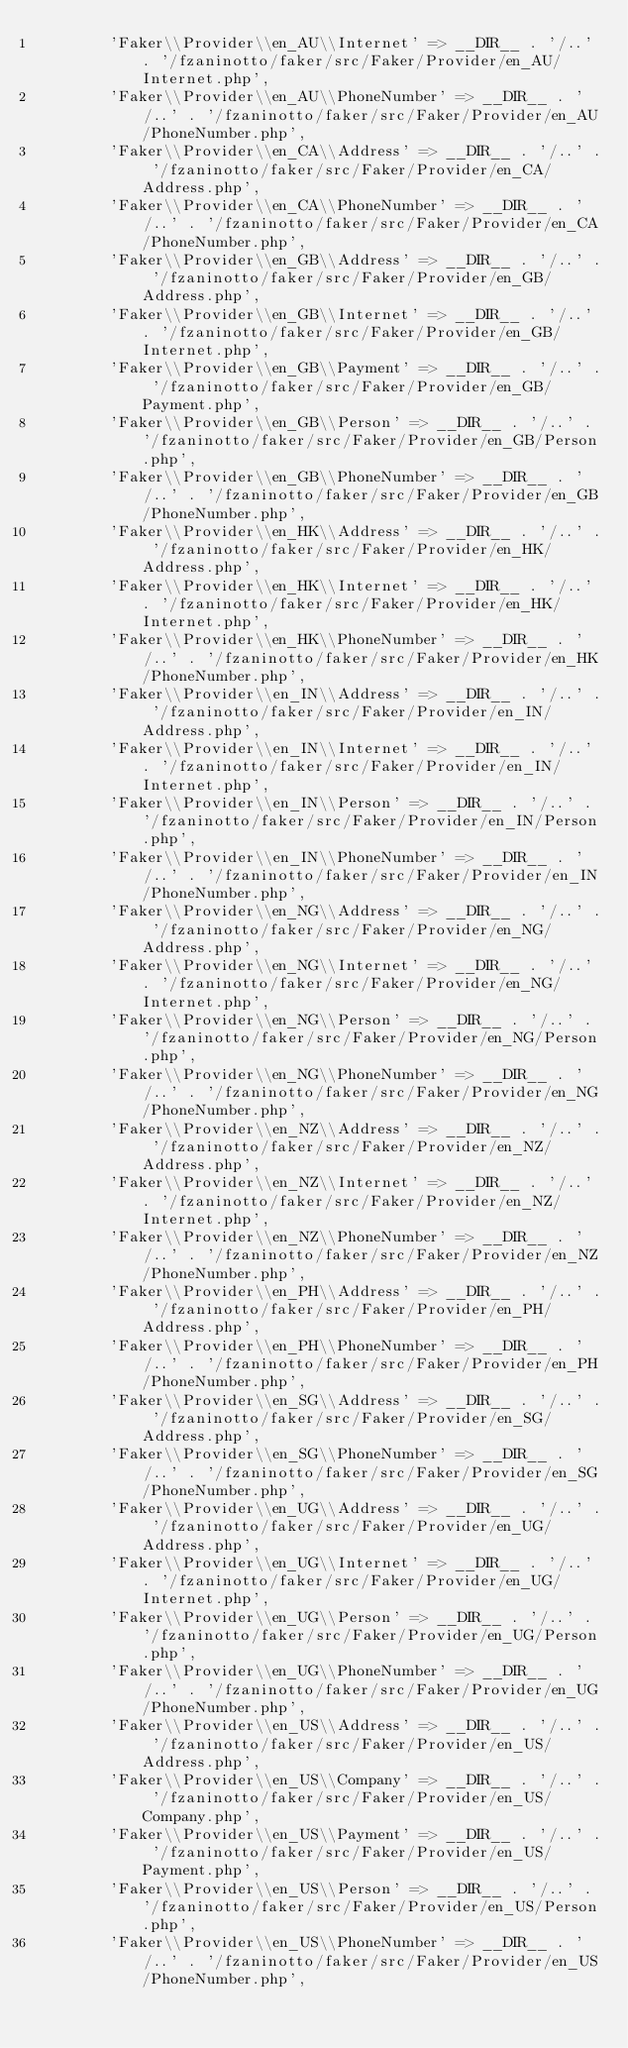Convert code to text. <code><loc_0><loc_0><loc_500><loc_500><_PHP_>        'Faker\\Provider\\en_AU\\Internet' => __DIR__ . '/..' . '/fzaninotto/faker/src/Faker/Provider/en_AU/Internet.php',
        'Faker\\Provider\\en_AU\\PhoneNumber' => __DIR__ . '/..' . '/fzaninotto/faker/src/Faker/Provider/en_AU/PhoneNumber.php',
        'Faker\\Provider\\en_CA\\Address' => __DIR__ . '/..' . '/fzaninotto/faker/src/Faker/Provider/en_CA/Address.php',
        'Faker\\Provider\\en_CA\\PhoneNumber' => __DIR__ . '/..' . '/fzaninotto/faker/src/Faker/Provider/en_CA/PhoneNumber.php',
        'Faker\\Provider\\en_GB\\Address' => __DIR__ . '/..' . '/fzaninotto/faker/src/Faker/Provider/en_GB/Address.php',
        'Faker\\Provider\\en_GB\\Internet' => __DIR__ . '/..' . '/fzaninotto/faker/src/Faker/Provider/en_GB/Internet.php',
        'Faker\\Provider\\en_GB\\Payment' => __DIR__ . '/..' . '/fzaninotto/faker/src/Faker/Provider/en_GB/Payment.php',
        'Faker\\Provider\\en_GB\\Person' => __DIR__ . '/..' . '/fzaninotto/faker/src/Faker/Provider/en_GB/Person.php',
        'Faker\\Provider\\en_GB\\PhoneNumber' => __DIR__ . '/..' . '/fzaninotto/faker/src/Faker/Provider/en_GB/PhoneNumber.php',
        'Faker\\Provider\\en_HK\\Address' => __DIR__ . '/..' . '/fzaninotto/faker/src/Faker/Provider/en_HK/Address.php',
        'Faker\\Provider\\en_HK\\Internet' => __DIR__ . '/..' . '/fzaninotto/faker/src/Faker/Provider/en_HK/Internet.php',
        'Faker\\Provider\\en_HK\\PhoneNumber' => __DIR__ . '/..' . '/fzaninotto/faker/src/Faker/Provider/en_HK/PhoneNumber.php',
        'Faker\\Provider\\en_IN\\Address' => __DIR__ . '/..' . '/fzaninotto/faker/src/Faker/Provider/en_IN/Address.php',
        'Faker\\Provider\\en_IN\\Internet' => __DIR__ . '/..' . '/fzaninotto/faker/src/Faker/Provider/en_IN/Internet.php',
        'Faker\\Provider\\en_IN\\Person' => __DIR__ . '/..' . '/fzaninotto/faker/src/Faker/Provider/en_IN/Person.php',
        'Faker\\Provider\\en_IN\\PhoneNumber' => __DIR__ . '/..' . '/fzaninotto/faker/src/Faker/Provider/en_IN/PhoneNumber.php',
        'Faker\\Provider\\en_NG\\Address' => __DIR__ . '/..' . '/fzaninotto/faker/src/Faker/Provider/en_NG/Address.php',
        'Faker\\Provider\\en_NG\\Internet' => __DIR__ . '/..' . '/fzaninotto/faker/src/Faker/Provider/en_NG/Internet.php',
        'Faker\\Provider\\en_NG\\Person' => __DIR__ . '/..' . '/fzaninotto/faker/src/Faker/Provider/en_NG/Person.php',
        'Faker\\Provider\\en_NG\\PhoneNumber' => __DIR__ . '/..' . '/fzaninotto/faker/src/Faker/Provider/en_NG/PhoneNumber.php',
        'Faker\\Provider\\en_NZ\\Address' => __DIR__ . '/..' . '/fzaninotto/faker/src/Faker/Provider/en_NZ/Address.php',
        'Faker\\Provider\\en_NZ\\Internet' => __DIR__ . '/..' . '/fzaninotto/faker/src/Faker/Provider/en_NZ/Internet.php',
        'Faker\\Provider\\en_NZ\\PhoneNumber' => __DIR__ . '/..' . '/fzaninotto/faker/src/Faker/Provider/en_NZ/PhoneNumber.php',
        'Faker\\Provider\\en_PH\\Address' => __DIR__ . '/..' . '/fzaninotto/faker/src/Faker/Provider/en_PH/Address.php',
        'Faker\\Provider\\en_PH\\PhoneNumber' => __DIR__ . '/..' . '/fzaninotto/faker/src/Faker/Provider/en_PH/PhoneNumber.php',
        'Faker\\Provider\\en_SG\\Address' => __DIR__ . '/..' . '/fzaninotto/faker/src/Faker/Provider/en_SG/Address.php',
        'Faker\\Provider\\en_SG\\PhoneNumber' => __DIR__ . '/..' . '/fzaninotto/faker/src/Faker/Provider/en_SG/PhoneNumber.php',
        'Faker\\Provider\\en_UG\\Address' => __DIR__ . '/..' . '/fzaninotto/faker/src/Faker/Provider/en_UG/Address.php',
        'Faker\\Provider\\en_UG\\Internet' => __DIR__ . '/..' . '/fzaninotto/faker/src/Faker/Provider/en_UG/Internet.php',
        'Faker\\Provider\\en_UG\\Person' => __DIR__ . '/..' . '/fzaninotto/faker/src/Faker/Provider/en_UG/Person.php',
        'Faker\\Provider\\en_UG\\PhoneNumber' => __DIR__ . '/..' . '/fzaninotto/faker/src/Faker/Provider/en_UG/PhoneNumber.php',
        'Faker\\Provider\\en_US\\Address' => __DIR__ . '/..' . '/fzaninotto/faker/src/Faker/Provider/en_US/Address.php',
        'Faker\\Provider\\en_US\\Company' => __DIR__ . '/..' . '/fzaninotto/faker/src/Faker/Provider/en_US/Company.php',
        'Faker\\Provider\\en_US\\Payment' => __DIR__ . '/..' . '/fzaninotto/faker/src/Faker/Provider/en_US/Payment.php',
        'Faker\\Provider\\en_US\\Person' => __DIR__ . '/..' . '/fzaninotto/faker/src/Faker/Provider/en_US/Person.php',
        'Faker\\Provider\\en_US\\PhoneNumber' => __DIR__ . '/..' . '/fzaninotto/faker/src/Faker/Provider/en_US/PhoneNumber.php',</code> 